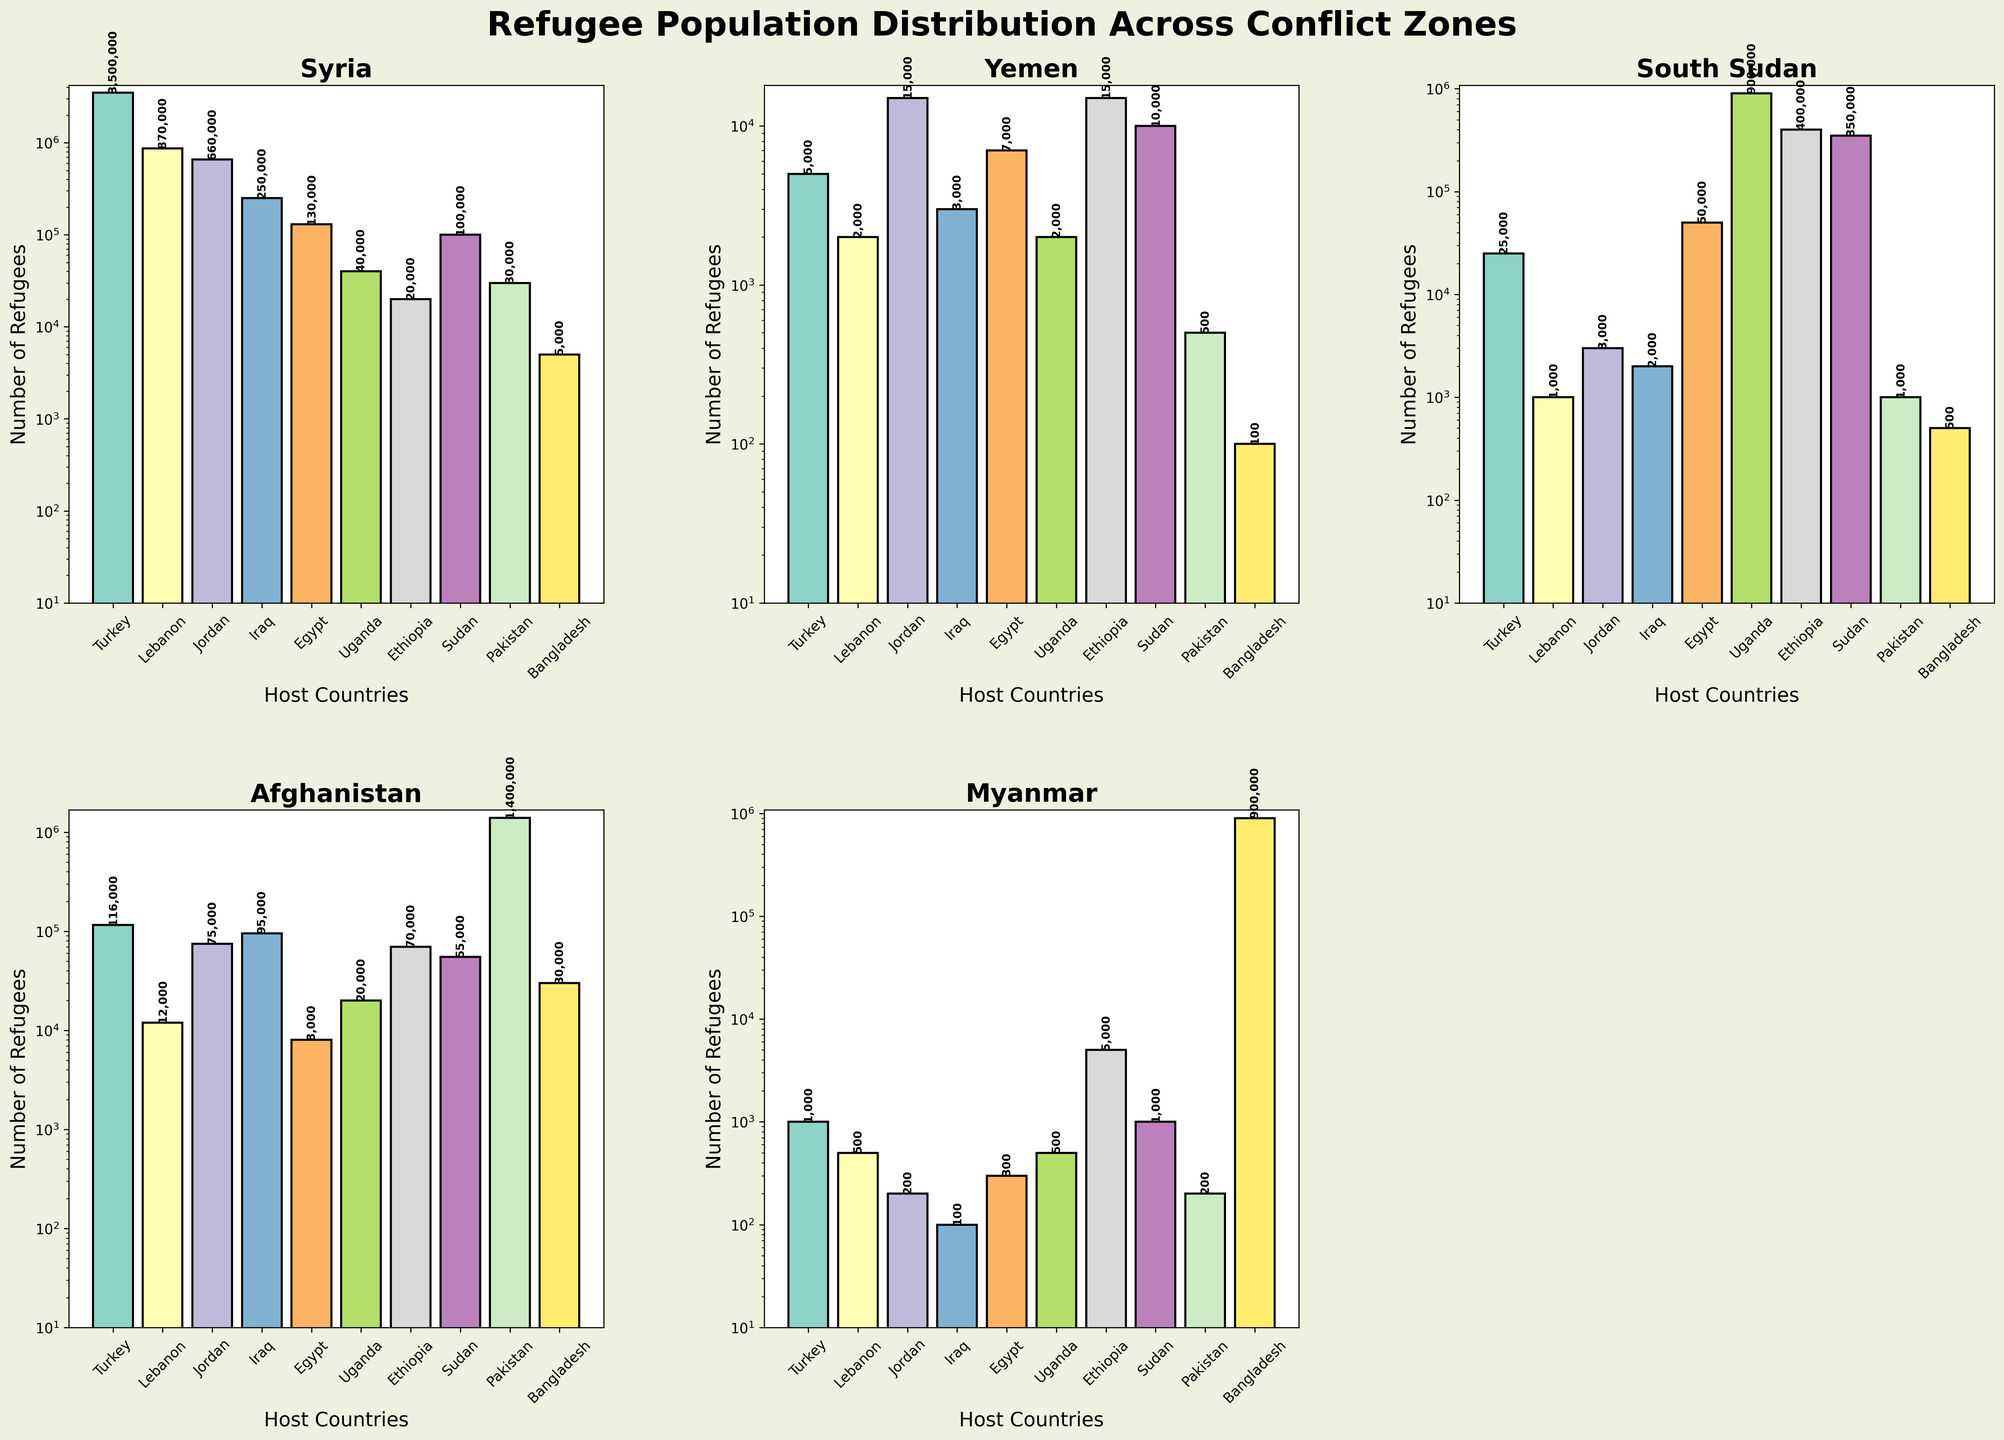What is the title of the figure? The figure has a main title that describes the overall topic it is presenting. It is placed at the top center of the figure.
Answer: Refugee Population Distribution Across Conflict Zones Which country hosts the highest number of Syrian refugees? By looking at the bar heights for Syria in each subplot corresponding to the different countries, the tallest bar indicates the highest number.
Answer: Turkey How many refugees from Afghanistan are hosted by Uganda and Pakistan combined? First, find the number of Afghan refugees in Uganda and Pakistan from their respective bars, then sum these values together. Uganda has 20,000 and Pakistan has 1,400,000 Afghan refugees. 20,000 + 1,400,000 = 1,420,000.
Answer: 1,420,000 Which conflict zone has more refugees in Egypt: Yemen or South Sudan? Compare the heights of the bars for Egypt under Yemen and South Sudan subplots. Yemen has 7,000 and South Sudan has 50,000.
Answer: South Sudan How does the number of refugees from Myanmar in Bangladesh compare to Thailand? In Bangladesh, the bar for Myanmar refugees is considerably taller than any other, indicating a significantly higher number. Bangladesh has 900,000 while other countries have lower numbers.
Answer: More in Bangladesh What is the number of Syrian refugees in Pakistan? Locate the bar representing Pakistan in the Syria subplot and read the value next to it.
Answer: 30,000 Which two conflict zones have the closest number of refugees hosted by Ethiopia? Identify the two bars closest in height in the Ethiopia subplot. Yemen and Myanmar both have approximately the same number of refugees. Yemen has 15,000 and Myanmar has 5,000.
Answer: Yemen and Myanmar How many countries host more than 100,000 refugees from Afghanistan? Check which countries have bars exceeding the 100,000 mark in the Afghanistan subplot. These are Jordan, Iraq, and Pakistan.
Answer: 3 countries Which conflict zone has the widest range of refugees hosted by different countries? Look for the conflict zone subplot where the values (bar heights) have the largest difference between the maximum and minimum values. Afghanistan ranges from 8,000 to 1,400,000.
Answer: Afghanistan What is the total number of refugees from South Sudan hosted by Uganda, Ethiopia, and Sudan combined? Sum the number of South Sudan refugees hosted by Uganda (900,000), Ethiopia (400,000), and Sudan (350,000). 900,000 + 400,000 + 350,000 = 1,650,000.
Answer: 1,650,000 